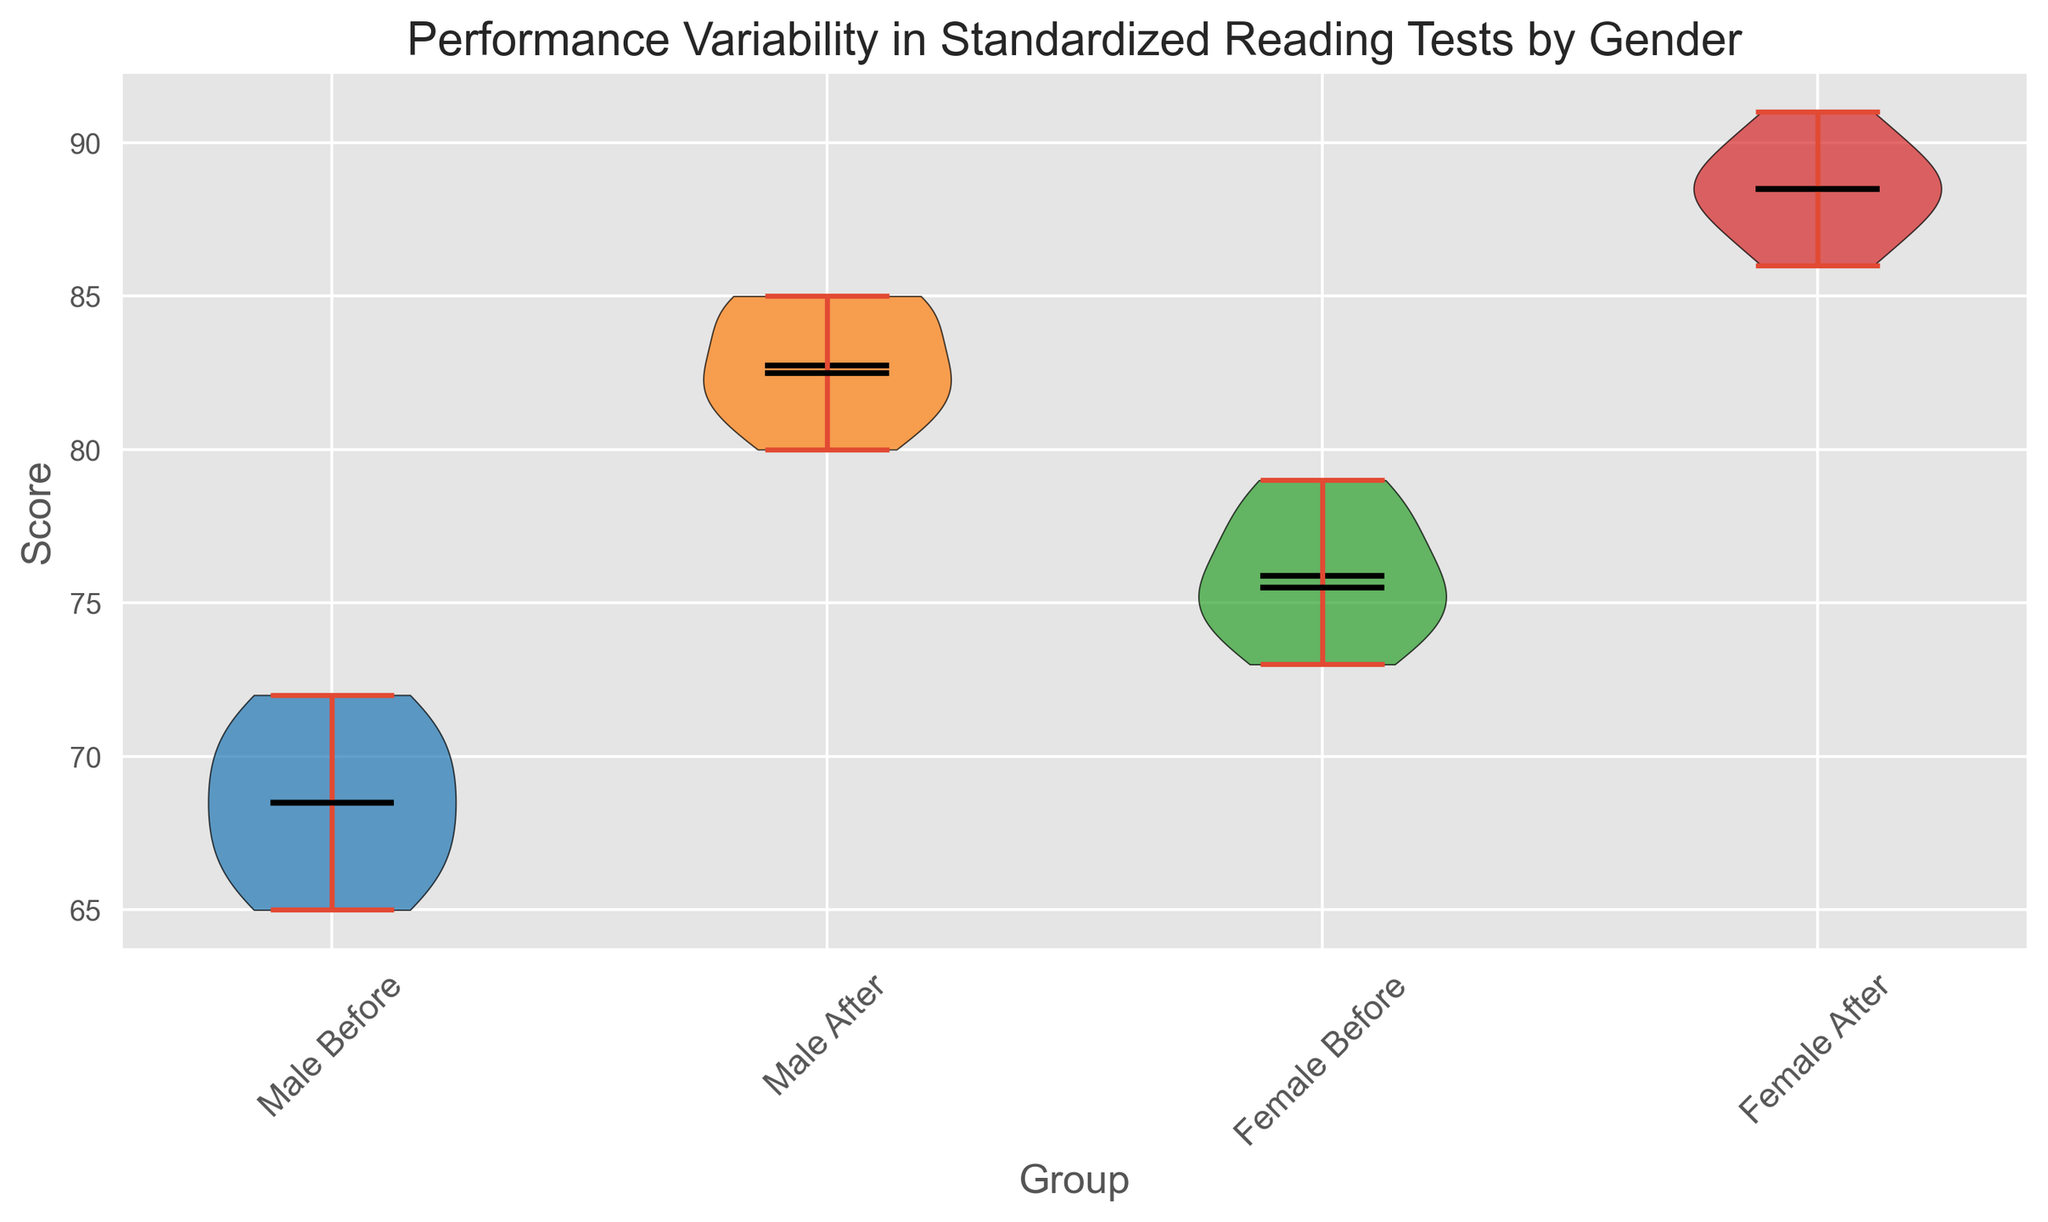Which group has the highest median score? To find the group with the highest median score, observe the median lines (black) in each violin plot. The 'Female After' group has the highest median score.
Answer: Female After What is the median score for males after program participation? The median score is represented by the black line in the 'Male After' violin plot. Identify and read the value of the line.
Answer: 83.5 Which group experienced the most improvement in average score after the program? Calculate the difference between the before and after mean scores in each gender. The improvement is visible where the 'After' mean is significantly higher than the 'Before' mean. Compare these values for both genders.
Answer: Female Are the score distributions wider before or after the program for females? Compare the width of the violin plots for 'Female Before' and 'Female After'. The width indicates the score variability.
Answer: Before Which group has the least variability in scores after participating in the program? Look for the narrowest violin plot in the 'After' groups. The 'Male After' plot shows less variability compared to 'Female After'.
Answer: Male After 